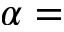<formula> <loc_0><loc_0><loc_500><loc_500>\alpha =</formula> 